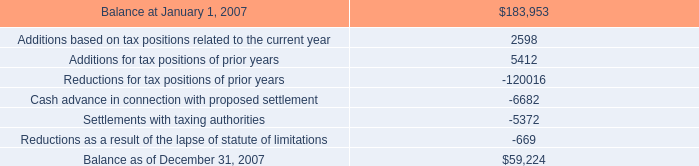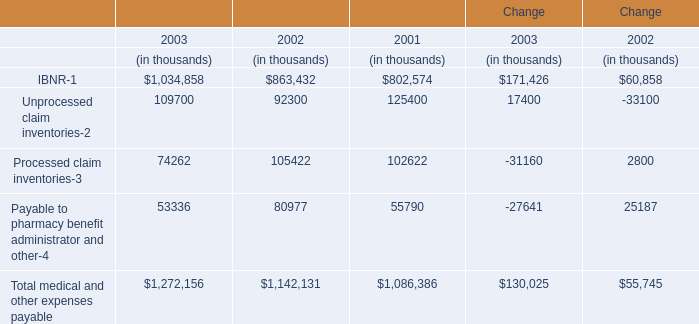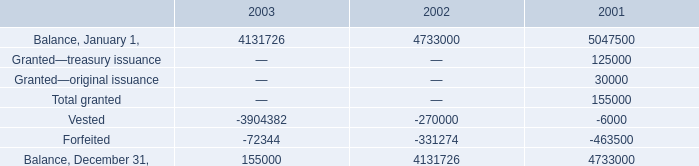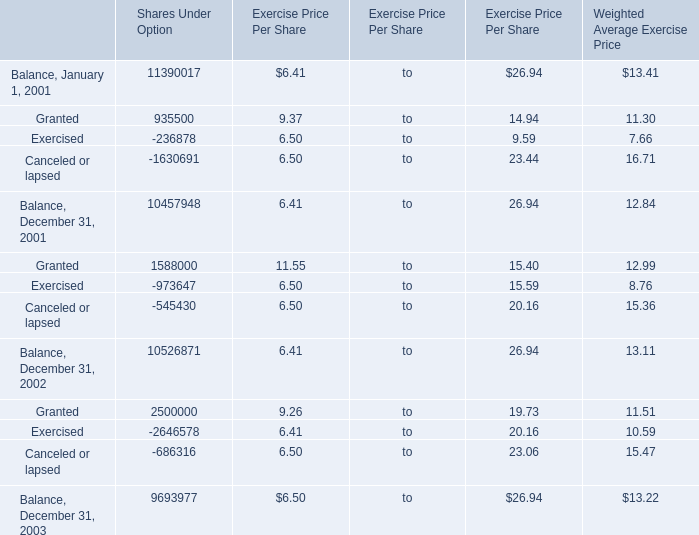What is the sum of Granted, Exercised and Canceled or lapsed in Balance, December 31,2001 for Shares Under Option? 
Computations: ((1588000 - 973647) - 545430)
Answer: 68923.0. 